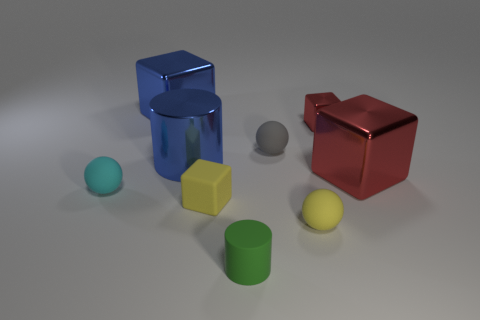Subtract all blue cylinders. How many red cubes are left? 2 Subtract all metallic blocks. How many blocks are left? 1 Subtract all blue blocks. How many blocks are left? 3 Add 1 brown blocks. How many objects exist? 10 Subtract all green blocks. Subtract all cyan balls. How many blocks are left? 4 Subtract all cubes. How many objects are left? 5 Subtract all yellow rubber cubes. Subtract all big red objects. How many objects are left? 7 Add 7 gray things. How many gray things are left? 8 Add 1 tiny green rubber objects. How many tiny green rubber objects exist? 2 Subtract 1 yellow spheres. How many objects are left? 8 